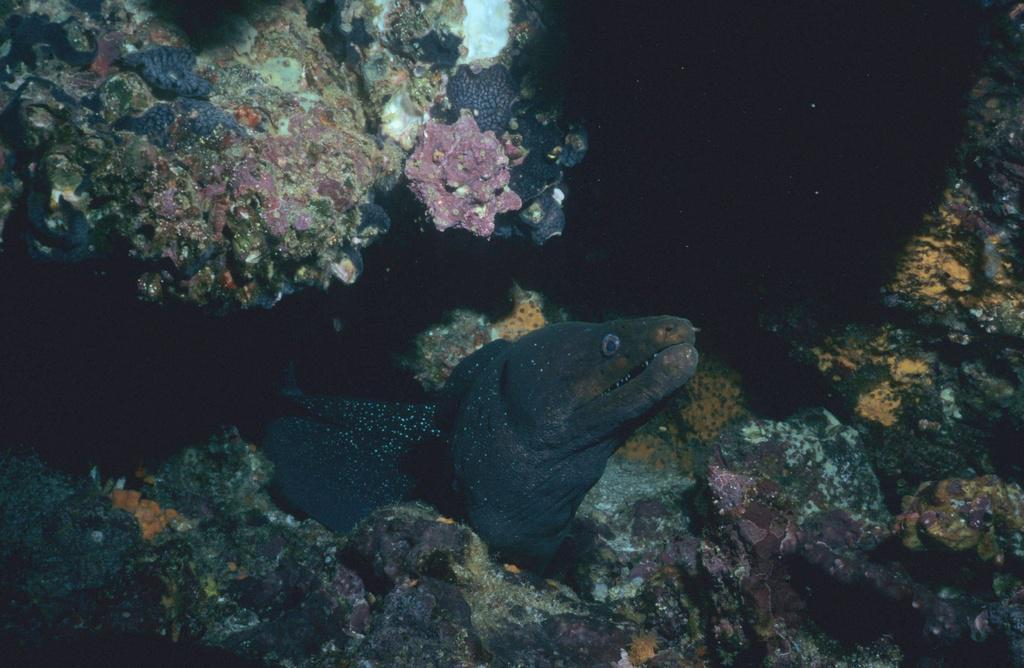What type of animal is in the image? There is a fish in the image. Where is the fish located? The fish is underwater. What can be seen in the background of the image? There is a coral reef in the image. What type of furniture is visible in the image? There is no furniture present in the image; it features a fish underwater near a coral reef. 